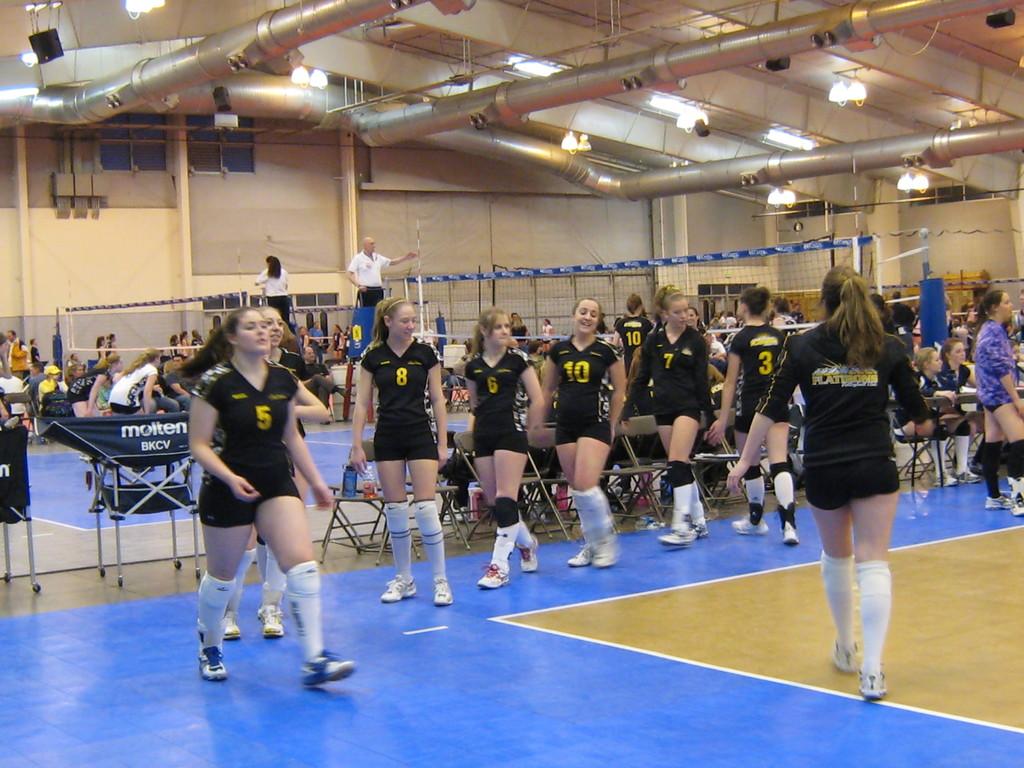What number is the player walking forward on the left?
Make the answer very short. 5. 